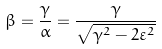Convert formula to latex. <formula><loc_0><loc_0><loc_500><loc_500>\beta = \frac { \gamma } { \alpha } = \frac { \gamma } { \sqrt { \gamma ^ { 2 } - 2 \varepsilon ^ { 2 } } }</formula> 